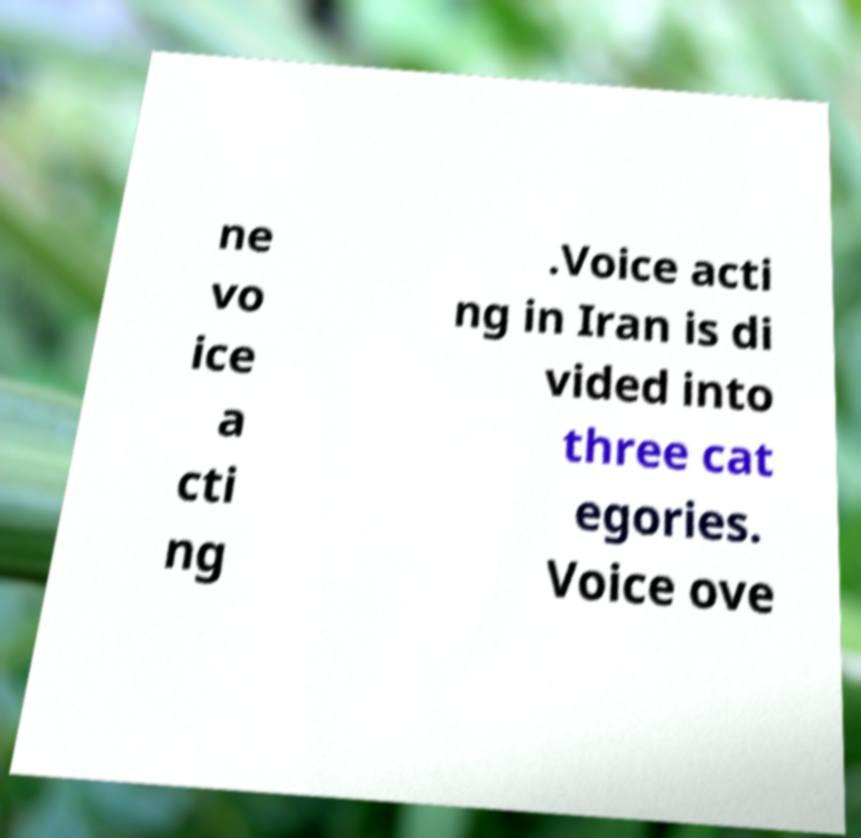Please read and relay the text visible in this image. What does it say? ne vo ice a cti ng .Voice acti ng in Iran is di vided into three cat egories. Voice ove 